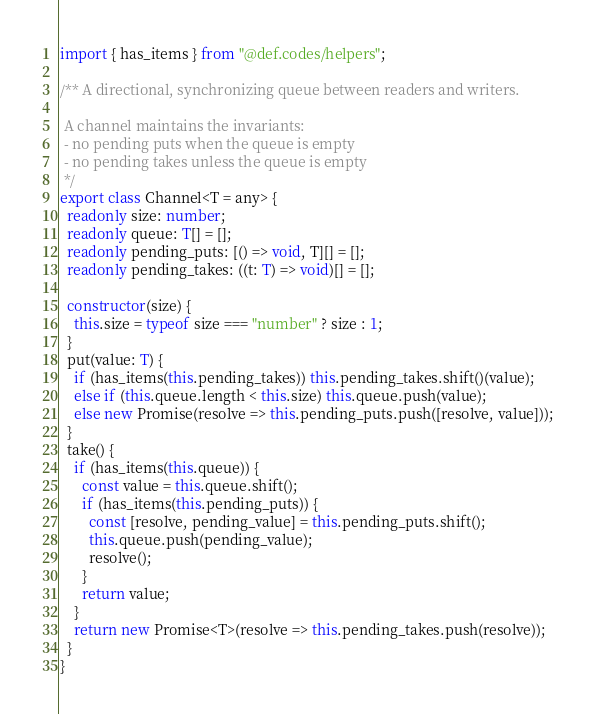<code> <loc_0><loc_0><loc_500><loc_500><_TypeScript_>import { has_items } from "@def.codes/helpers";

/** A directional, synchronizing queue between readers and writers.

 A channel maintains the invariants:
 - no pending puts when the queue is empty
 - no pending takes unless the queue is empty
 */
export class Channel<T = any> {
  readonly size: number;
  readonly queue: T[] = [];
  readonly pending_puts: [() => void, T][] = [];
  readonly pending_takes: ((t: T) => void)[] = [];

  constructor(size) {
    this.size = typeof size === "number" ? size : 1;
  }
  put(value: T) {
    if (has_items(this.pending_takes)) this.pending_takes.shift()(value);
    else if (this.queue.length < this.size) this.queue.push(value);
    else new Promise(resolve => this.pending_puts.push([resolve, value]));
  }
  take() {
    if (has_items(this.queue)) {
      const value = this.queue.shift();
      if (has_items(this.pending_puts)) {
        const [resolve, pending_value] = this.pending_puts.shift();
        this.queue.push(pending_value);
        resolve();
      }
      return value;
    }
    return new Promise<T>(resolve => this.pending_takes.push(resolve));
  }
}
</code> 